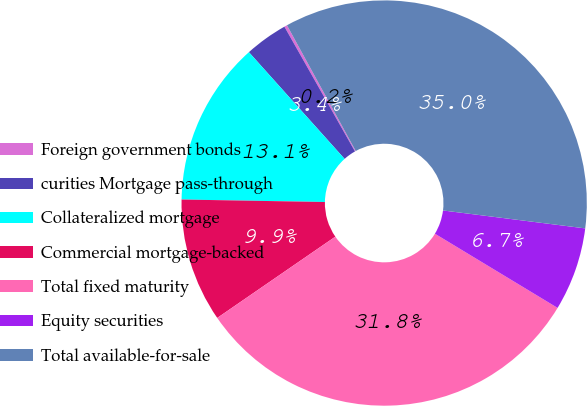<chart> <loc_0><loc_0><loc_500><loc_500><pie_chart><fcel>Foreign government bonds<fcel>curities Mortgage pass-through<fcel>Collateralized mortgage<fcel>Commercial mortgage-backed<fcel>Total fixed maturity<fcel>Equity securities<fcel>Total available-for-sale<nl><fcel>0.23%<fcel>3.44%<fcel>13.09%<fcel>9.87%<fcel>31.75%<fcel>6.66%<fcel>34.96%<nl></chart> 